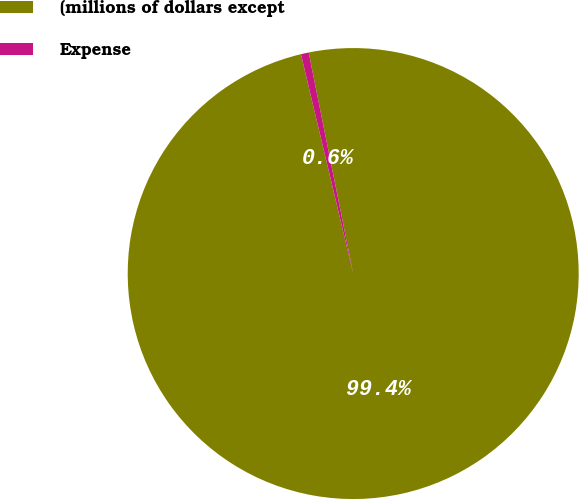<chart> <loc_0><loc_0><loc_500><loc_500><pie_chart><fcel>(millions of dollars except<fcel>Expense<nl><fcel>99.44%<fcel>0.56%<nl></chart> 